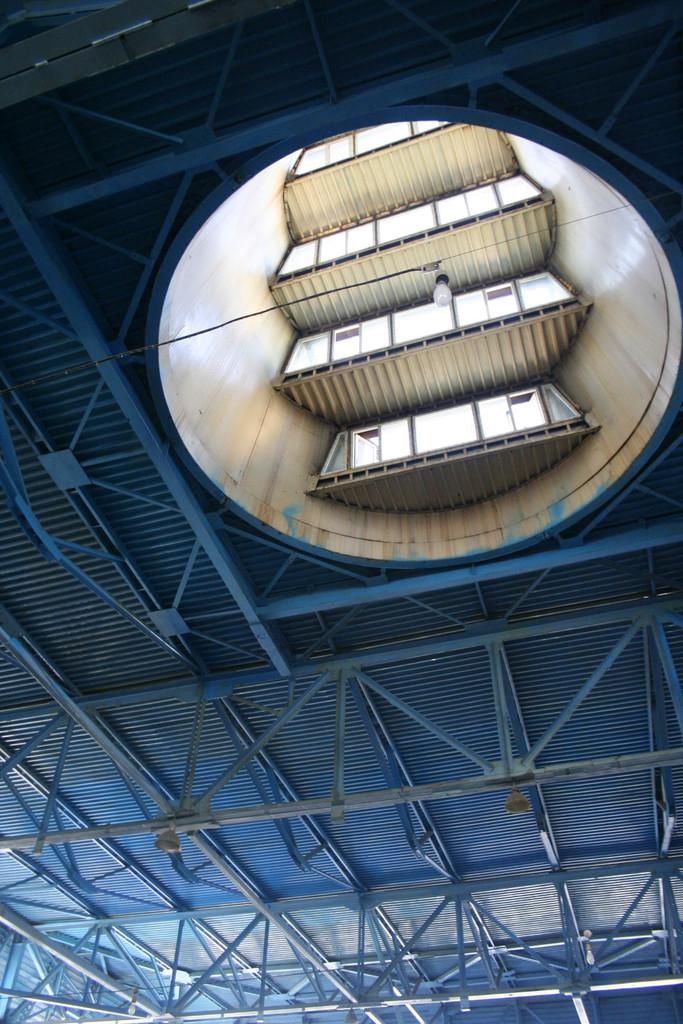What type of structure is present in the image? There is a shed in the image. What material are the rods in the image made of? The rods in the image are made of metal. What can be used to provide illumination in the image? There are lights in the image. What type of rhythm can be heard coming from the shed in the image? There is no indication of any sound or rhythm in the image, as it only features a shed, metal rods, and lights. 